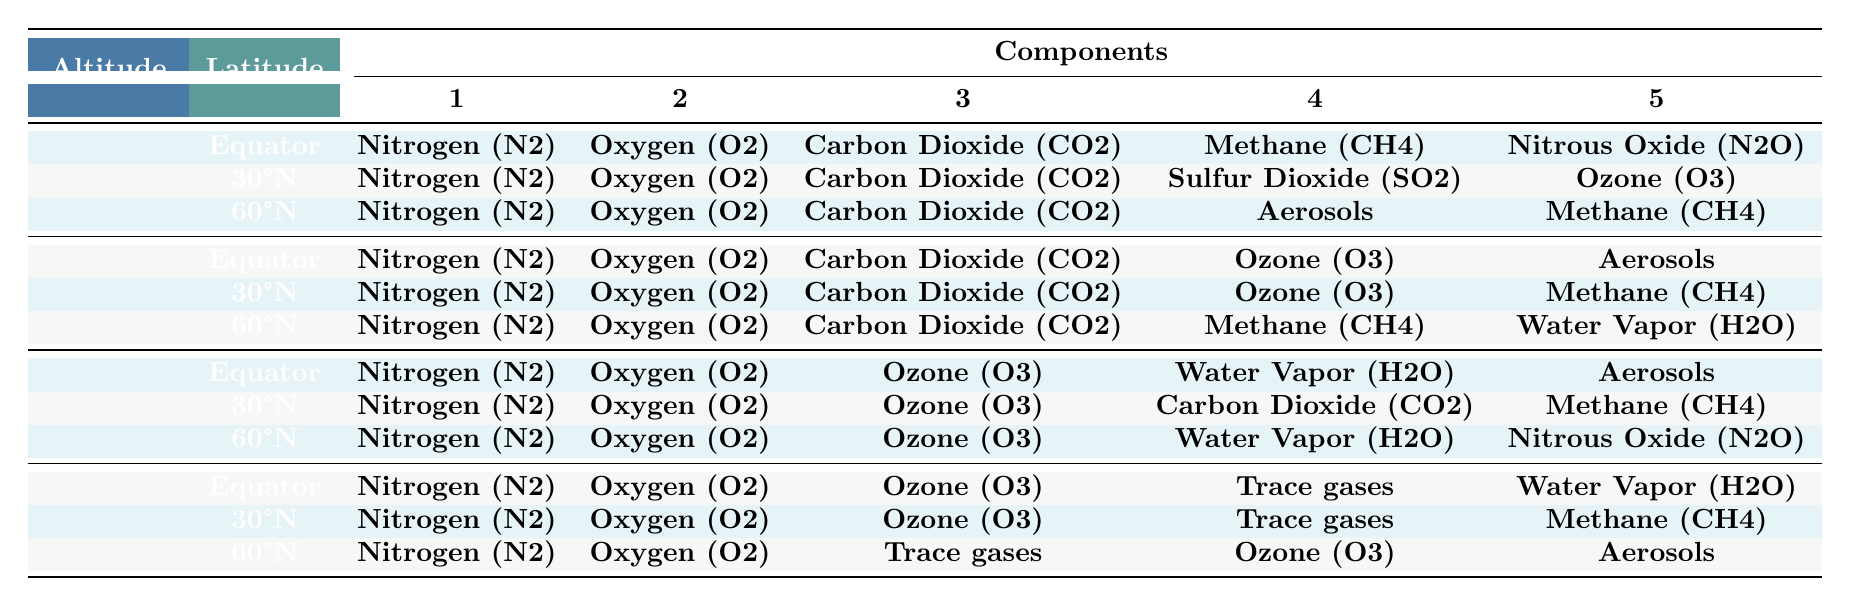What are the main components of the atmosphere at an altitude of 0-1 km near the Equator? The components listed in the table for the 0-1 km altitude at the Equator are Nitrogen (N2), Oxygen (O2), Carbon Dioxide (CO2), Methane (CH4), and Nitrous Oxide (N2O).
Answer: Nitrogen (N2), Oxygen (O2), Carbon Dioxide (CO2), Methane (CH4), Nitrous Oxide (N2O) Is Sulfur Dioxide (SO2) present in the atmospheric composition at 60°N latitude? The table shows that Sulfur Dioxide (SO2) is not listed under the components for 60°N; it is only noted for 30°N at 0-1 km.
Answer: No Which altitude has the highest occurrence of Water Vapor (H2O) in its components? Water Vapor (H2O) appears at 1-5 km for 60°N, 5-10 km for Equator and 60°N, and at 10-20 km for Equator, but it is present at all mentioned altitude categories.
Answer: Altitudes 1-5 km, 5-10 km, and 10-20 km all have Water Vapor How many different components appear at 10-20 km and 30°N latitude? For 10-20 km at 30°N, the components are Nitrogen (N2), Oxygen (O2), Ozone (O3), Trace gases, and Methane (CH4). That sums to 5 components.
Answer: 5 components What is the difference in the number of components listed between the 0-1 km and 10-20 km layers at the Equator? At 0-1 km, there are 5 components, and at 10-20 km, there are also 5 components. The difference is 5 - 5 = 0.
Answer: 0 Are there any components that appear at both 1-5 km and 5-10 km altitudes at 30°N? The components Nitrogen (N2), Oxygen (O2), and Ozone (O3) are present in both altitudes at 30°N. Thus, yes, there are common components.
Answer: Yes At which altitude does Ozone (O3) first appear in the components for 60°N latitude? Ozone (O3) first appears in the 1-5 km altitude for 60°N, as it is not mentioned in the 0-1 km section for that latitude.
Answer: 1-5 km If Methane (CH4) constitutes a component at 30°N in both the 0-1 km and 1-5 km layers, how many total altitude sections include Methane (CH4) for 30°N in the table? Methane (CH4) is included in both the 0-1 km and 1-5 km sections for 30°N, but not in the 5-10 km or 10-20 km. So, it appears in 2 sections.
Answer: 2 sections 